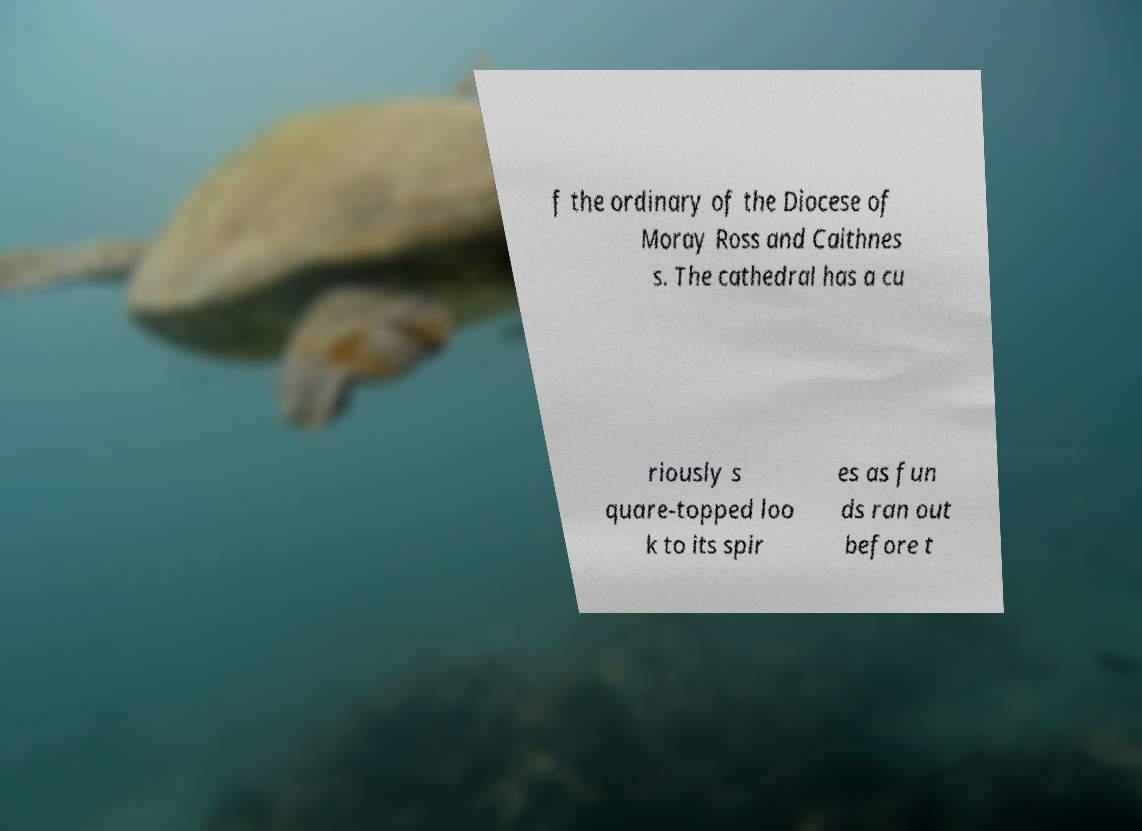Can you read and provide the text displayed in the image?This photo seems to have some interesting text. Can you extract and type it out for me? f the ordinary of the Diocese of Moray Ross and Caithnes s. The cathedral has a cu riously s quare-topped loo k to its spir es as fun ds ran out before t 